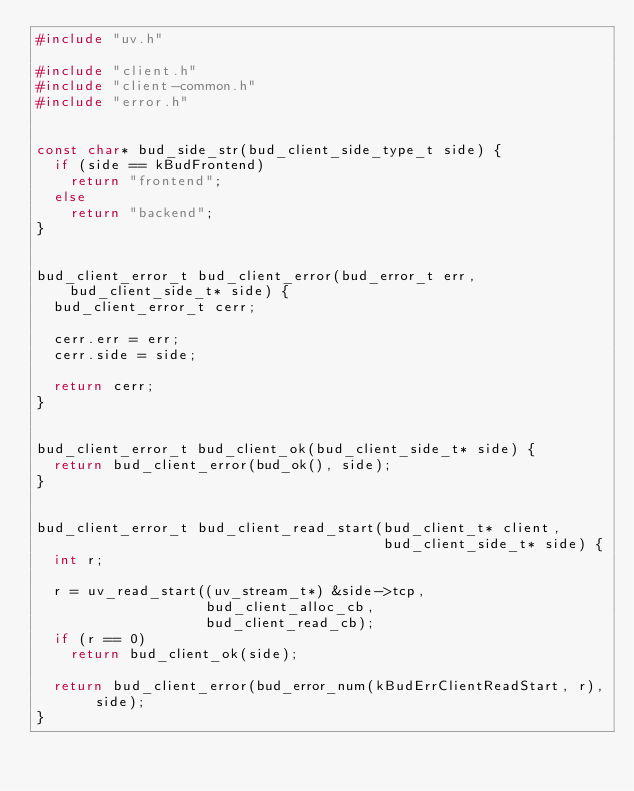Convert code to text. <code><loc_0><loc_0><loc_500><loc_500><_C_>#include "uv.h"

#include "client.h"
#include "client-common.h"
#include "error.h"


const char* bud_side_str(bud_client_side_type_t side) {
  if (side == kBudFrontend)
    return "frontend";
  else
    return "backend";
}


bud_client_error_t bud_client_error(bud_error_t err, bud_client_side_t* side) {
  bud_client_error_t cerr;

  cerr.err = err;
  cerr.side = side;

  return cerr;
}


bud_client_error_t bud_client_ok(bud_client_side_t* side) {
  return bud_client_error(bud_ok(), side);
}


bud_client_error_t bud_client_read_start(bud_client_t* client,
                                         bud_client_side_t* side) {
  int r;

  r = uv_read_start((uv_stream_t*) &side->tcp,
                    bud_client_alloc_cb,
                    bud_client_read_cb);
  if (r == 0)
    return bud_client_ok(side);

  return bud_client_error(bud_error_num(kBudErrClientReadStart, r), side);
}
</code> 